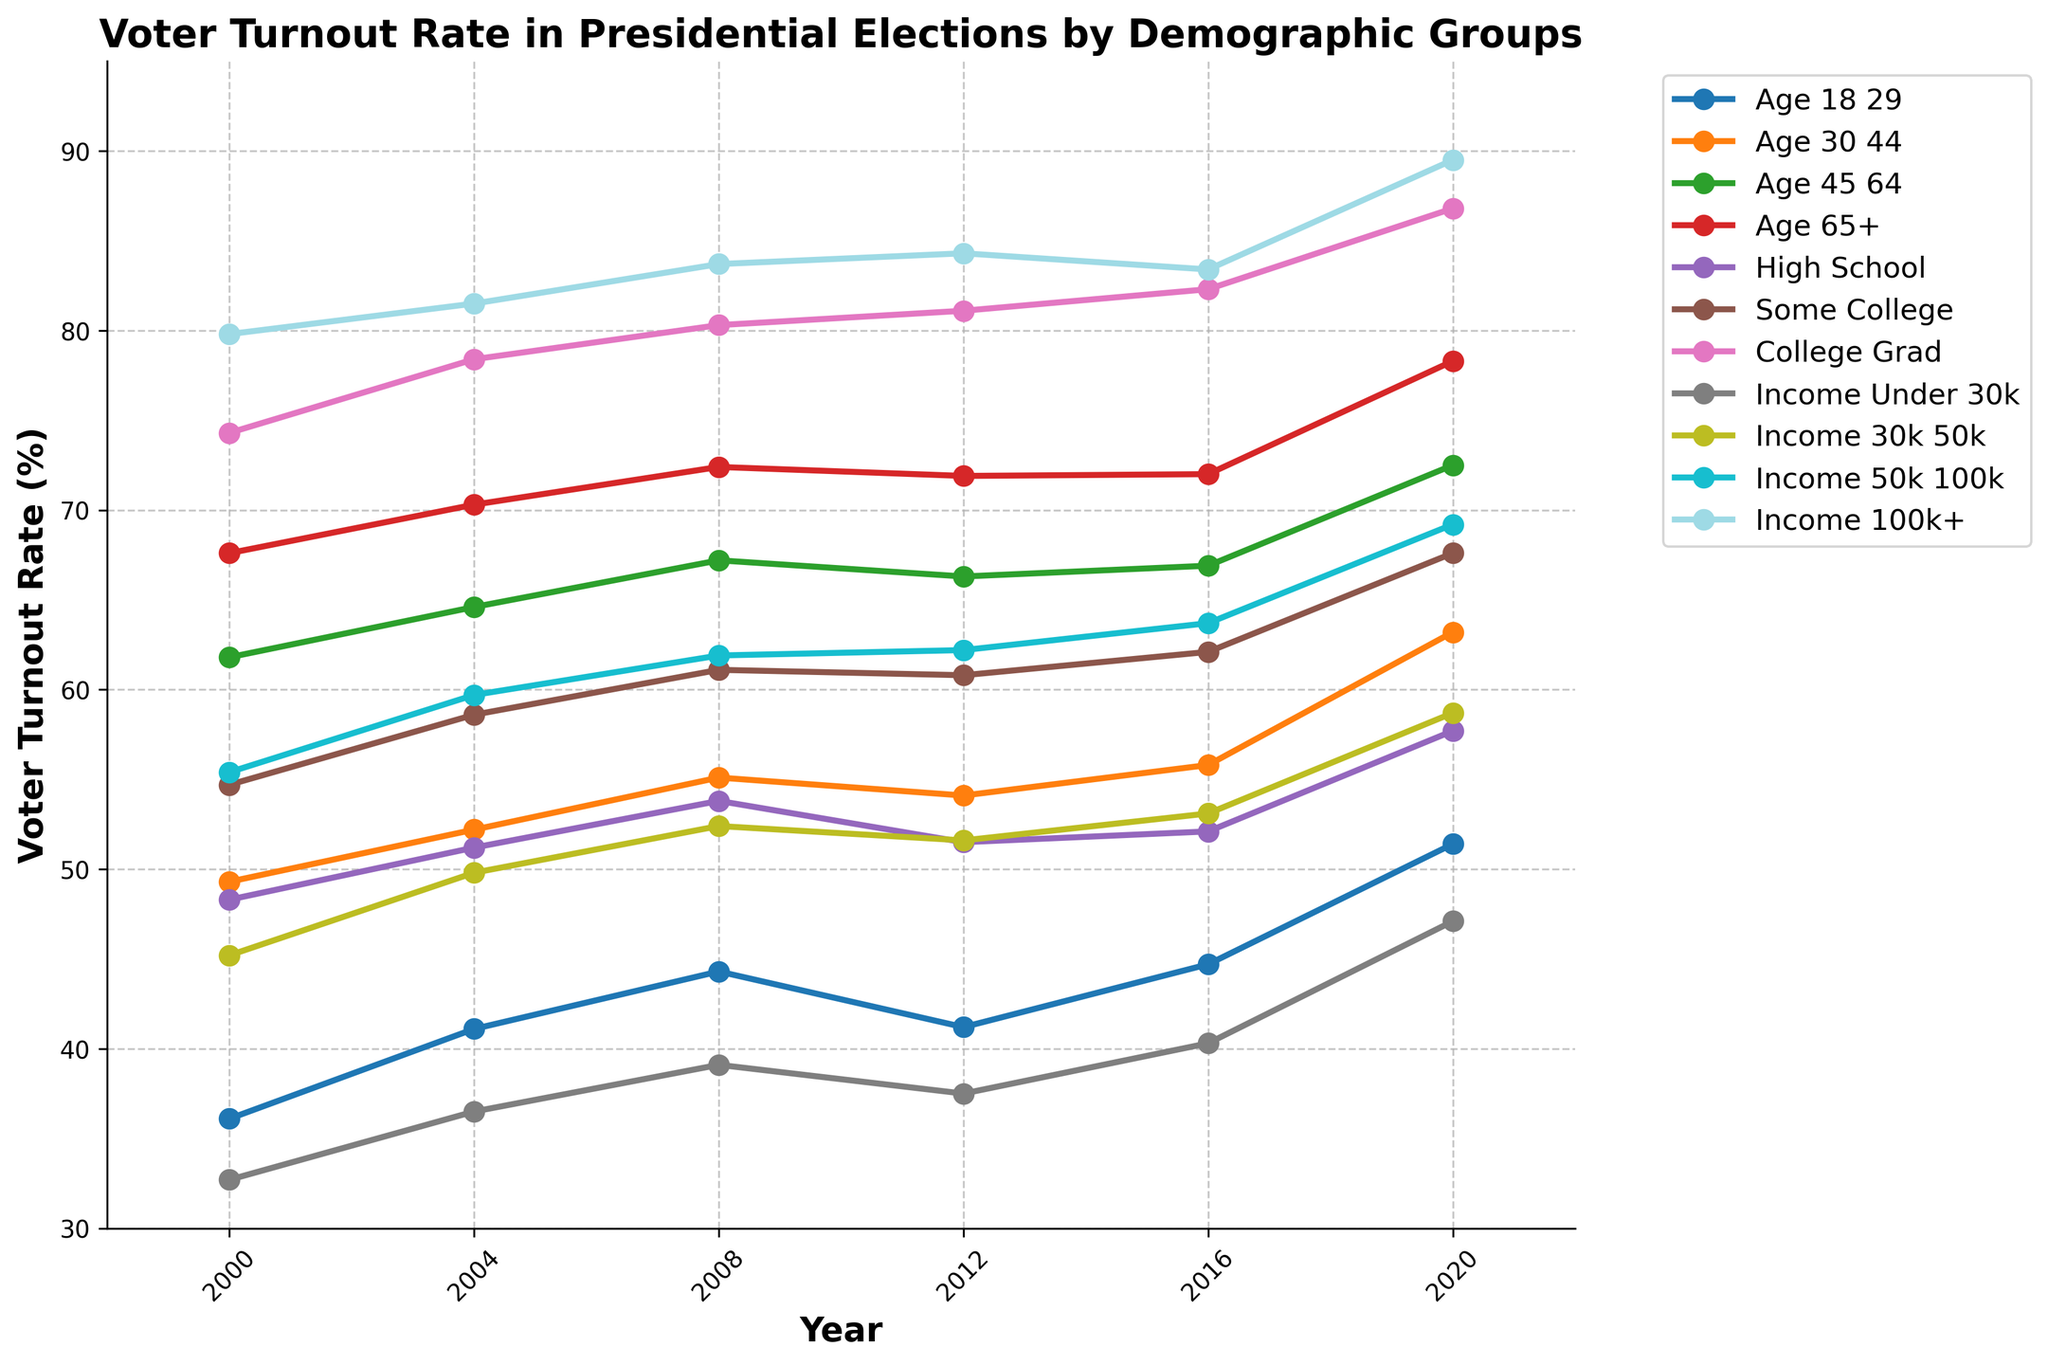What demographic group consistently has the highest voter turnout rate? The line representing the "College Grad" group consistently appears above all other lines in the plot across all years, indicating the highest voter turnout rate.
Answer: College Grad How did the voter turnout rate for the "Income 100k+" group change from 2000 to 2020? In 2000, the voter turnout rate for the "Income 100k+" group was 79.8%. In 2020, it increased to 89.5%.
Answer: Increased by 9.7% What was the voter turnout rate for the "Age 18-29" group in 2008, and how does it compare to 2020? In 2008, the voter turnout rate for the "Age 18-29" group was 44.3%, and in 2020, it was 51.4%.
Answer: Higher by 7.1% Between which two consecutive years did the "High School" group see the greatest increase in voter turnout rate? From the plot, the greatest increase for the "High School" group appears between 2016 and 2020, where the rate increased from 52.1% to 57.7%.
Answer: 2016 to 2020 Which demographic group had the lowest voter turnout rate in 2004? In the plot for the year 2004, the "Income Under 30k" group line is the lowest, indicating the lowest voter turnout rate of 36.5%.
Answer: Income Under 30k What is the average voter turnout rate across all groups in 2016? To find the average, sum the voter turnout rates for all groups in 2016 and divide by the number of groups: (44.7 + 55.8 + 66.9 + 72.0 + 52.1 + 62.1 + 82.3 + 40.3 + 53.1 + 63.7 + 83.4) / 11 = 624.4 / 11 ≈ 56.76%
Answer: 56.76% Which age group saw the most significant increase in voter turnout rate from 2016 to 2020? By examining the plot from 2016 to 2020, the "Age 18-29" group saw an increase from 44.7% to 51.4%, which is a 6.7% increase, the highest among age groups.
Answer: Age 18-29 How did voter turnout rates differ between "Some College" and "College Grad" in 2012? In 2012, the voter turnout rate for "Some College" was 60.8%, while for "College Grad" it was 81.1%.
Answer: 20.3% higher for College Grad Did any demographic group's voter turnout rate decrease from 2008 to 2012? The voter turnout rate for the "Age 18-29" group decreased from 44.3% in 2008 to 41.2% in 2012.
Answer: Yes, Age 18-29 